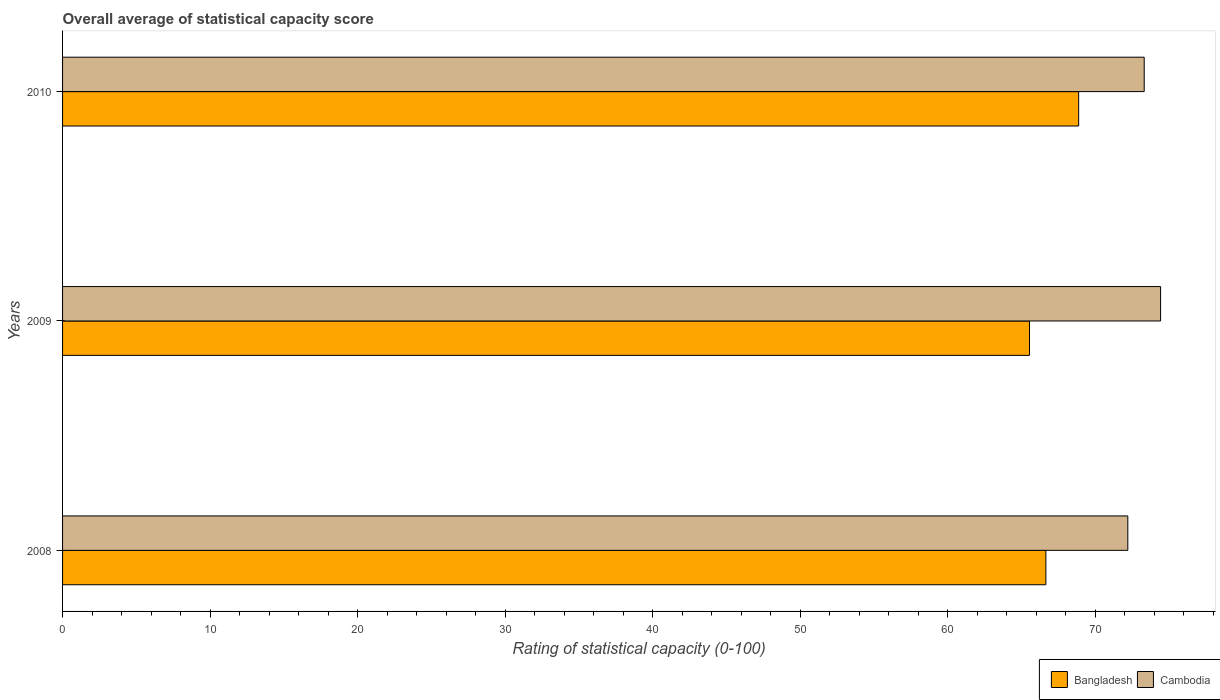How many groups of bars are there?
Your answer should be very brief. 3. Are the number of bars per tick equal to the number of legend labels?
Offer a very short reply. Yes. How many bars are there on the 1st tick from the top?
Your answer should be very brief. 2. What is the rating of statistical capacity in Cambodia in 2008?
Give a very brief answer. 72.22. Across all years, what is the maximum rating of statistical capacity in Cambodia?
Provide a short and direct response. 74.44. Across all years, what is the minimum rating of statistical capacity in Cambodia?
Ensure brevity in your answer.  72.22. What is the total rating of statistical capacity in Cambodia in the graph?
Provide a succinct answer. 220. What is the difference between the rating of statistical capacity in Bangladesh in 2008 and that in 2010?
Your response must be concise. -2.22. What is the difference between the rating of statistical capacity in Bangladesh in 2009 and the rating of statistical capacity in Cambodia in 2008?
Offer a very short reply. -6.67. What is the average rating of statistical capacity in Cambodia per year?
Offer a very short reply. 73.33. In the year 2009, what is the difference between the rating of statistical capacity in Cambodia and rating of statistical capacity in Bangladesh?
Your response must be concise. 8.89. In how many years, is the rating of statistical capacity in Cambodia greater than 8 ?
Ensure brevity in your answer.  3. What is the ratio of the rating of statistical capacity in Bangladesh in 2008 to that in 2009?
Give a very brief answer. 1.02. What is the difference between the highest and the second highest rating of statistical capacity in Bangladesh?
Your response must be concise. 2.22. What is the difference between the highest and the lowest rating of statistical capacity in Cambodia?
Your answer should be compact. 2.22. Is the sum of the rating of statistical capacity in Cambodia in 2009 and 2010 greater than the maximum rating of statistical capacity in Bangladesh across all years?
Give a very brief answer. Yes. What does the 1st bar from the top in 2008 represents?
Ensure brevity in your answer.  Cambodia. What does the 2nd bar from the bottom in 2009 represents?
Provide a succinct answer. Cambodia. Are all the bars in the graph horizontal?
Your answer should be very brief. Yes. How many years are there in the graph?
Offer a terse response. 3. What is the difference between two consecutive major ticks on the X-axis?
Provide a succinct answer. 10. Where does the legend appear in the graph?
Offer a terse response. Bottom right. How many legend labels are there?
Offer a terse response. 2. What is the title of the graph?
Offer a very short reply. Overall average of statistical capacity score. What is the label or title of the X-axis?
Give a very brief answer. Rating of statistical capacity (0-100). What is the label or title of the Y-axis?
Offer a terse response. Years. What is the Rating of statistical capacity (0-100) in Bangladesh in 2008?
Your answer should be compact. 66.67. What is the Rating of statistical capacity (0-100) in Cambodia in 2008?
Offer a terse response. 72.22. What is the Rating of statistical capacity (0-100) in Bangladesh in 2009?
Keep it short and to the point. 65.56. What is the Rating of statistical capacity (0-100) in Cambodia in 2009?
Your response must be concise. 74.44. What is the Rating of statistical capacity (0-100) of Bangladesh in 2010?
Your response must be concise. 68.89. What is the Rating of statistical capacity (0-100) in Cambodia in 2010?
Your answer should be very brief. 73.33. Across all years, what is the maximum Rating of statistical capacity (0-100) in Bangladesh?
Ensure brevity in your answer.  68.89. Across all years, what is the maximum Rating of statistical capacity (0-100) of Cambodia?
Make the answer very short. 74.44. Across all years, what is the minimum Rating of statistical capacity (0-100) of Bangladesh?
Provide a short and direct response. 65.56. Across all years, what is the minimum Rating of statistical capacity (0-100) in Cambodia?
Make the answer very short. 72.22. What is the total Rating of statistical capacity (0-100) in Bangladesh in the graph?
Your answer should be compact. 201.11. What is the total Rating of statistical capacity (0-100) of Cambodia in the graph?
Your answer should be very brief. 220. What is the difference between the Rating of statistical capacity (0-100) in Cambodia in 2008 and that in 2009?
Keep it short and to the point. -2.22. What is the difference between the Rating of statistical capacity (0-100) in Bangladesh in 2008 and that in 2010?
Ensure brevity in your answer.  -2.22. What is the difference between the Rating of statistical capacity (0-100) in Cambodia in 2008 and that in 2010?
Your answer should be very brief. -1.11. What is the difference between the Rating of statistical capacity (0-100) of Bangladesh in 2009 and that in 2010?
Make the answer very short. -3.33. What is the difference between the Rating of statistical capacity (0-100) in Bangladesh in 2008 and the Rating of statistical capacity (0-100) in Cambodia in 2009?
Your answer should be compact. -7.78. What is the difference between the Rating of statistical capacity (0-100) of Bangladesh in 2008 and the Rating of statistical capacity (0-100) of Cambodia in 2010?
Ensure brevity in your answer.  -6.67. What is the difference between the Rating of statistical capacity (0-100) in Bangladesh in 2009 and the Rating of statistical capacity (0-100) in Cambodia in 2010?
Give a very brief answer. -7.78. What is the average Rating of statistical capacity (0-100) in Bangladesh per year?
Provide a succinct answer. 67.04. What is the average Rating of statistical capacity (0-100) of Cambodia per year?
Ensure brevity in your answer.  73.33. In the year 2008, what is the difference between the Rating of statistical capacity (0-100) in Bangladesh and Rating of statistical capacity (0-100) in Cambodia?
Your response must be concise. -5.56. In the year 2009, what is the difference between the Rating of statistical capacity (0-100) in Bangladesh and Rating of statistical capacity (0-100) in Cambodia?
Your answer should be compact. -8.89. In the year 2010, what is the difference between the Rating of statistical capacity (0-100) of Bangladesh and Rating of statistical capacity (0-100) of Cambodia?
Make the answer very short. -4.44. What is the ratio of the Rating of statistical capacity (0-100) in Bangladesh in 2008 to that in 2009?
Ensure brevity in your answer.  1.02. What is the ratio of the Rating of statistical capacity (0-100) in Cambodia in 2008 to that in 2009?
Your answer should be very brief. 0.97. What is the ratio of the Rating of statistical capacity (0-100) of Bangladesh in 2008 to that in 2010?
Offer a very short reply. 0.97. What is the ratio of the Rating of statistical capacity (0-100) of Bangladesh in 2009 to that in 2010?
Provide a succinct answer. 0.95. What is the ratio of the Rating of statistical capacity (0-100) in Cambodia in 2009 to that in 2010?
Keep it short and to the point. 1.02. What is the difference between the highest and the second highest Rating of statistical capacity (0-100) in Bangladesh?
Offer a very short reply. 2.22. What is the difference between the highest and the lowest Rating of statistical capacity (0-100) in Bangladesh?
Keep it short and to the point. 3.33. What is the difference between the highest and the lowest Rating of statistical capacity (0-100) in Cambodia?
Your answer should be very brief. 2.22. 